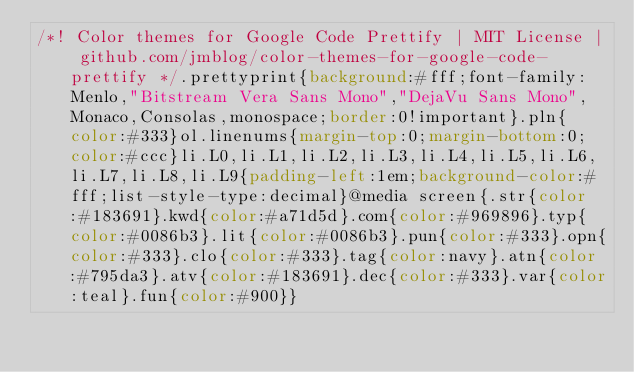<code> <loc_0><loc_0><loc_500><loc_500><_CSS_>/*! Color themes for Google Code Prettify | MIT License | github.com/jmblog/color-themes-for-google-code-prettify */.prettyprint{background:#fff;font-family:Menlo,"Bitstream Vera Sans Mono","DejaVu Sans Mono",Monaco,Consolas,monospace;border:0!important}.pln{color:#333}ol.linenums{margin-top:0;margin-bottom:0;color:#ccc}li.L0,li.L1,li.L2,li.L3,li.L4,li.L5,li.L6,li.L7,li.L8,li.L9{padding-left:1em;background-color:#fff;list-style-type:decimal}@media screen{.str{color:#183691}.kwd{color:#a71d5d}.com{color:#969896}.typ{color:#0086b3}.lit{color:#0086b3}.pun{color:#333}.opn{color:#333}.clo{color:#333}.tag{color:navy}.atn{color:#795da3}.atv{color:#183691}.dec{color:#333}.var{color:teal}.fun{color:#900}}</code> 